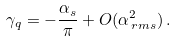Convert formula to latex. <formula><loc_0><loc_0><loc_500><loc_500>\gamma _ { q } = - \frac { \alpha _ { s } } { \pi } + O ( \alpha _ { \, r m s } ^ { 2 } ) \, .</formula> 